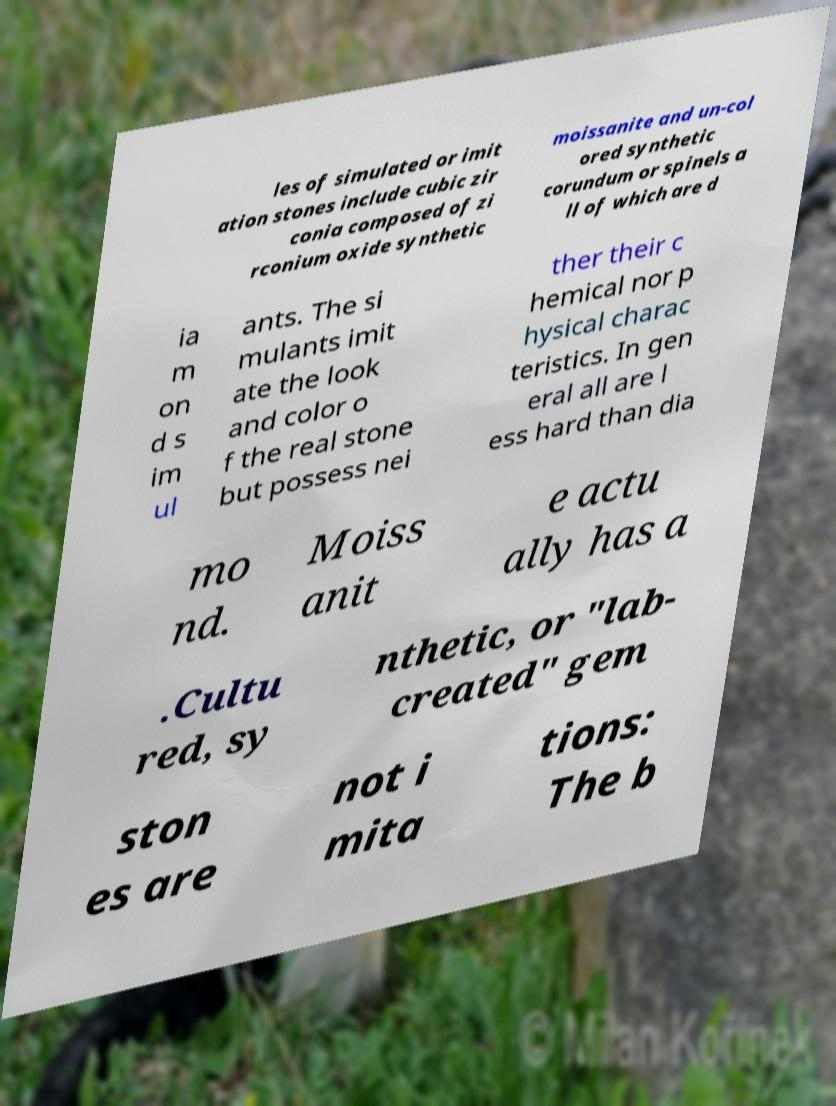Can you accurately transcribe the text from the provided image for me? les of simulated or imit ation stones include cubic zir conia composed of zi rconium oxide synthetic moissanite and un-col ored synthetic corundum or spinels a ll of which are d ia m on d s im ul ants. The si mulants imit ate the look and color o f the real stone but possess nei ther their c hemical nor p hysical charac teristics. In gen eral all are l ess hard than dia mo nd. Moiss anit e actu ally has a .Cultu red, sy nthetic, or "lab- created" gem ston es are not i mita tions: The b 